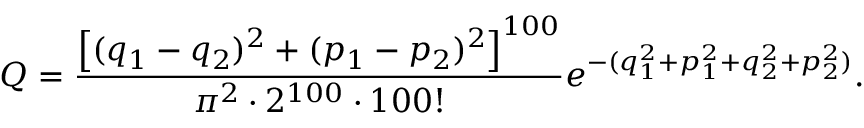Convert formula to latex. <formula><loc_0><loc_0><loc_500><loc_500>Q = \frac { \left [ ( q _ { 1 } - q _ { 2 } ) ^ { 2 } + ( p _ { 1 } - p _ { 2 } ) ^ { 2 } \right ] ^ { 1 0 0 } } { \pi ^ { 2 } \cdot 2 ^ { 1 0 0 } \cdot 1 0 0 ! } e ^ { - ( q _ { 1 } ^ { 2 } + p _ { 1 } ^ { 2 } + q _ { 2 } ^ { 2 } + p _ { 2 } ^ { 2 } ) } .</formula> 